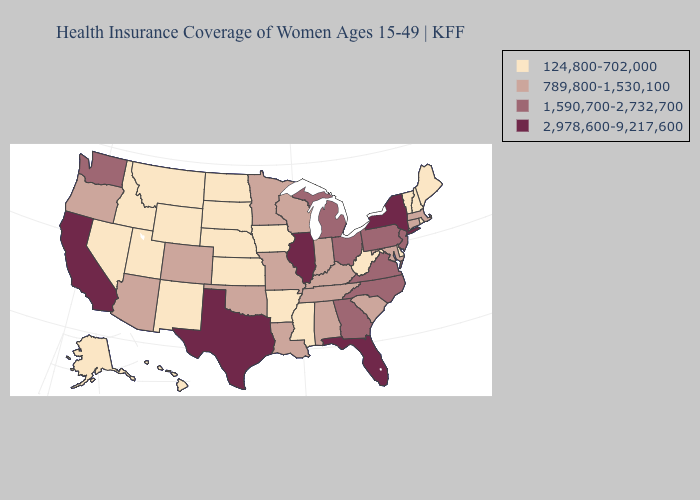Does the first symbol in the legend represent the smallest category?
Quick response, please. Yes. Among the states that border North Dakota , does South Dakota have the lowest value?
Quick response, please. Yes. Name the states that have a value in the range 1,590,700-2,732,700?
Keep it brief. Georgia, Michigan, New Jersey, North Carolina, Ohio, Pennsylvania, Virginia, Washington. Among the states that border Kentucky , which have the highest value?
Give a very brief answer. Illinois. Name the states that have a value in the range 1,590,700-2,732,700?
Give a very brief answer. Georgia, Michigan, New Jersey, North Carolina, Ohio, Pennsylvania, Virginia, Washington. Which states have the highest value in the USA?
Concise answer only. California, Florida, Illinois, New York, Texas. What is the highest value in states that border Maryland?
Write a very short answer. 1,590,700-2,732,700. Among the states that border Connecticut , does Rhode Island have the lowest value?
Write a very short answer. Yes. What is the value of Louisiana?
Give a very brief answer. 789,800-1,530,100. Does Georgia have the highest value in the USA?
Write a very short answer. No. Which states hav the highest value in the MidWest?
Be succinct. Illinois. Does New York have the same value as Rhode Island?
Answer briefly. No. What is the value of Idaho?
Give a very brief answer. 124,800-702,000. What is the value of Vermont?
Be succinct. 124,800-702,000. Does California have the highest value in the West?
Write a very short answer. Yes. 